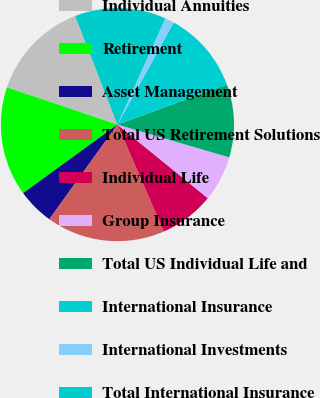<chart> <loc_0><loc_0><loc_500><loc_500><pie_chart><fcel>Individual Annuities<fcel>Retirement<fcel>Asset Management<fcel>Total US Retirement Solutions<fcel>Individual Life<fcel>Group Insurance<fcel>Total US Individual Life and<fcel>International Insurance<fcel>International Investments<fcel>Total International Insurance<nl><fcel>13.92%<fcel>15.18%<fcel>5.07%<fcel>16.45%<fcel>7.6%<fcel>6.34%<fcel>10.13%<fcel>11.39%<fcel>1.28%<fcel>12.65%<nl></chart> 